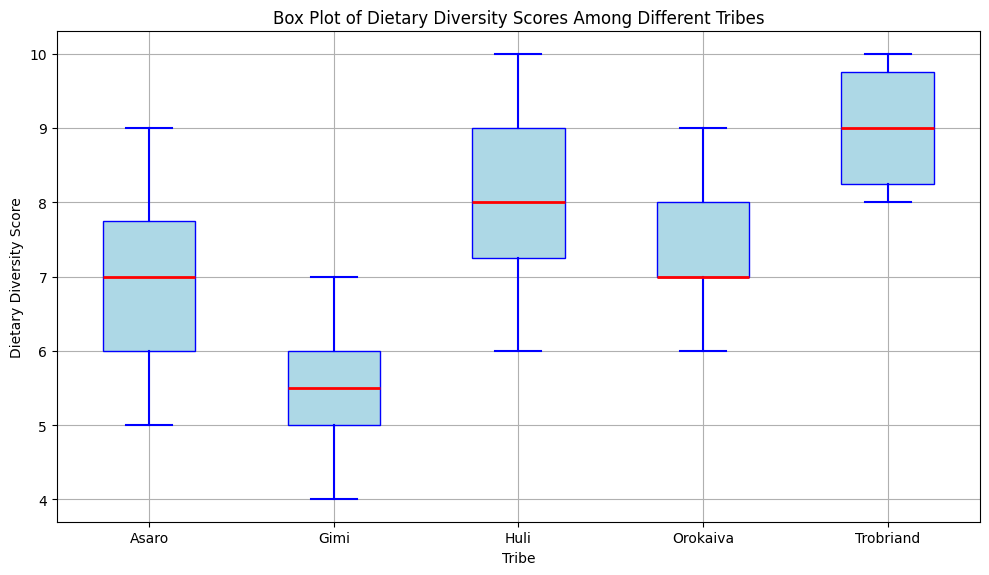What is the median Dietary Diversity Score for the Huli tribe? The box plot shows a red line within the box for each tribe, indicating the median. For the Huli tribe, this red line corresponds to a score of 8.
Answer: 8 Which tribe has the highest median Dietary Diversity Score? Compare the median lines (red) of each tribe’s box. The Trobriand tribe has the highest median as its red line is at 9.
Answer: Trobriand How variable is the Dietary Diversity Score within the Gimi tribe compared to the Huli tribe? The variability in the Dietary Diversity Score is shown by the height of the boxes. The Gimi tribe's box is longer, indicating greater variability compared to the Huli tribe.
Answer: More variable What is the interquartile range (IQR) of the Dietary Diversity Scores for the Orokaiva tribe? The IQR is calculated as the difference between the third quartile (top of the box) and the first quartile (bottom of the box). For the Orokaiva tribe, the top of the box is at 8 and the bottom is at 7, resulting in an IQR of 1.
Answer: 1 Which tribe has the smallest range in Dietary Diversity Scores? The range is the difference between the whiskers' highest and lowest points. The Asaro tribe has the smallest range, indicated by the shortest distance between the whiskers.
Answer: Asaro How does the median Dietary Diversity Score of the Trobriand tribe compare to the median score of the Asaro tribe? The median of the Trobriand tribe (red line) is at 9, while the median of the Asaro tribe is at 7. The Trobriand tribe has a higher median score.
Answer: Higher Are there any outliers in the Dietary Diversity Scores for the Huli tribe? Outliers are noted by dots outside the whiskers. There are no dots outside the whiskers for the Huli tribe, indicating no outliers.
Answer: No What is the maximum Dietary Diversity Score for the Gimi tribe? The maximum Dietary Diversity Score is indicated by the top whisker for each tribe. For the Gimi tribe, the top whisker reaches 7.
Answer: 7 Which tribe has the widest interquartile range (IQR)? By comparing the height of the boxes (the distance between the first and third quartile), we can see that the Huli tribe has the widest IQR.
Answer: Huli Which tribe has the least median Dietary Diversity Score? Look at the position of the red median lines. The Gimi tribe has the least median at approximately 5.5.
Answer: Gimi 